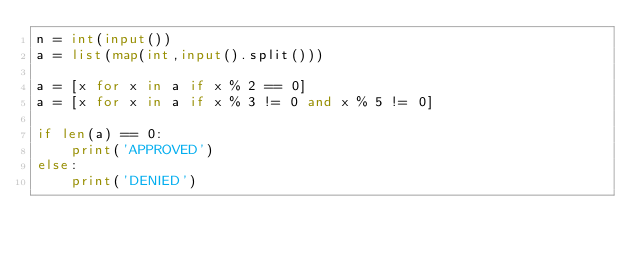<code> <loc_0><loc_0><loc_500><loc_500><_Python_>n = int(input())
a = list(map(int,input().split()))

a = [x for x in a if x % 2 == 0]
a = [x for x in a if x % 3 != 0 and x % 5 != 0]

if len(a) == 0:
    print('APPROVED')
else:
    print('DENIED')

</code> 